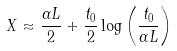<formula> <loc_0><loc_0><loc_500><loc_500>X \approx \frac { \alpha L } { 2 } + \frac { t _ { 0 } } { 2 } \log \left ( \frac { t _ { 0 } } { \alpha L } \right )</formula> 